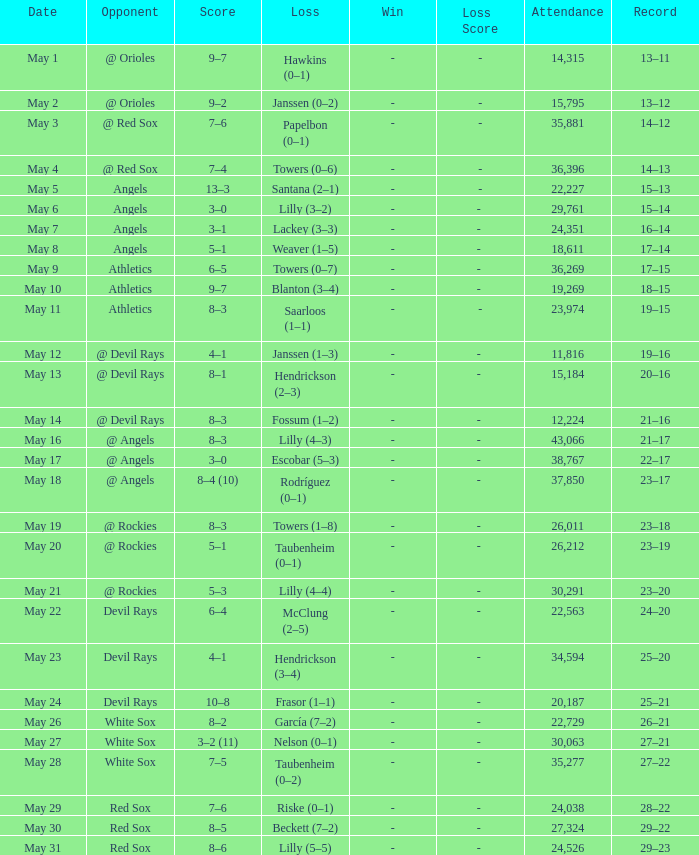What was the average presence for games with a setback of papelbon (0–1)? 35881.0. 